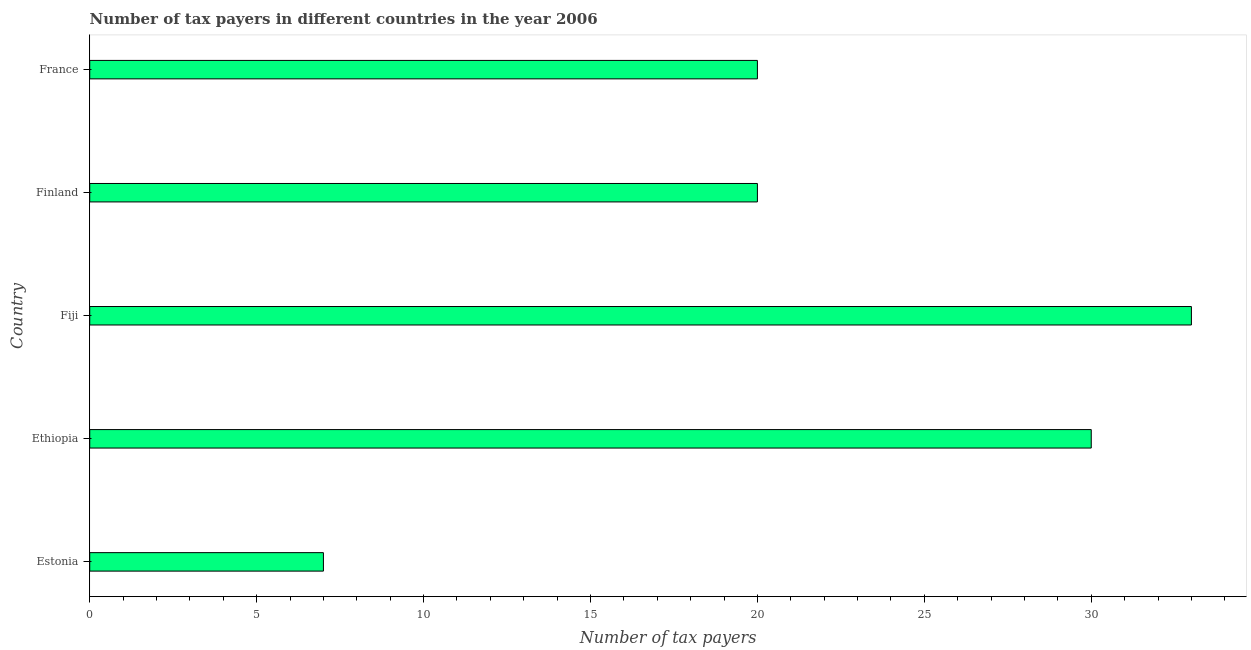Does the graph contain grids?
Ensure brevity in your answer.  No. What is the title of the graph?
Your answer should be compact. Number of tax payers in different countries in the year 2006. What is the label or title of the X-axis?
Your answer should be very brief. Number of tax payers. What is the label or title of the Y-axis?
Offer a very short reply. Country. Across all countries, what is the maximum number of tax payers?
Your response must be concise. 33. In which country was the number of tax payers maximum?
Offer a very short reply. Fiji. In which country was the number of tax payers minimum?
Keep it short and to the point. Estonia. What is the sum of the number of tax payers?
Offer a terse response. 110. What is the median number of tax payers?
Your response must be concise. 20. Is the difference between the number of tax payers in Fiji and France greater than the difference between any two countries?
Give a very brief answer. No. Is the sum of the number of tax payers in Estonia and Ethiopia greater than the maximum number of tax payers across all countries?
Ensure brevity in your answer.  Yes. What is the difference between the highest and the lowest number of tax payers?
Your response must be concise. 26. In how many countries, is the number of tax payers greater than the average number of tax payers taken over all countries?
Ensure brevity in your answer.  2. Are all the bars in the graph horizontal?
Your response must be concise. Yes. What is the difference between two consecutive major ticks on the X-axis?
Provide a short and direct response. 5. Are the values on the major ticks of X-axis written in scientific E-notation?
Your answer should be very brief. No. What is the Number of tax payers of Estonia?
Ensure brevity in your answer.  7. What is the Number of tax payers of Fiji?
Keep it short and to the point. 33. What is the difference between the Number of tax payers in Estonia and Ethiopia?
Keep it short and to the point. -23. What is the difference between the Number of tax payers in Estonia and Fiji?
Provide a succinct answer. -26. What is the difference between the Number of tax payers in Estonia and Finland?
Make the answer very short. -13. What is the difference between the Number of tax payers in Ethiopia and Finland?
Provide a succinct answer. 10. What is the difference between the Number of tax payers in Fiji and France?
Keep it short and to the point. 13. What is the ratio of the Number of tax payers in Estonia to that in Ethiopia?
Offer a very short reply. 0.23. What is the ratio of the Number of tax payers in Estonia to that in Fiji?
Make the answer very short. 0.21. What is the ratio of the Number of tax payers in Ethiopia to that in Fiji?
Provide a succinct answer. 0.91. What is the ratio of the Number of tax payers in Fiji to that in Finland?
Your response must be concise. 1.65. What is the ratio of the Number of tax payers in Fiji to that in France?
Offer a terse response. 1.65. 